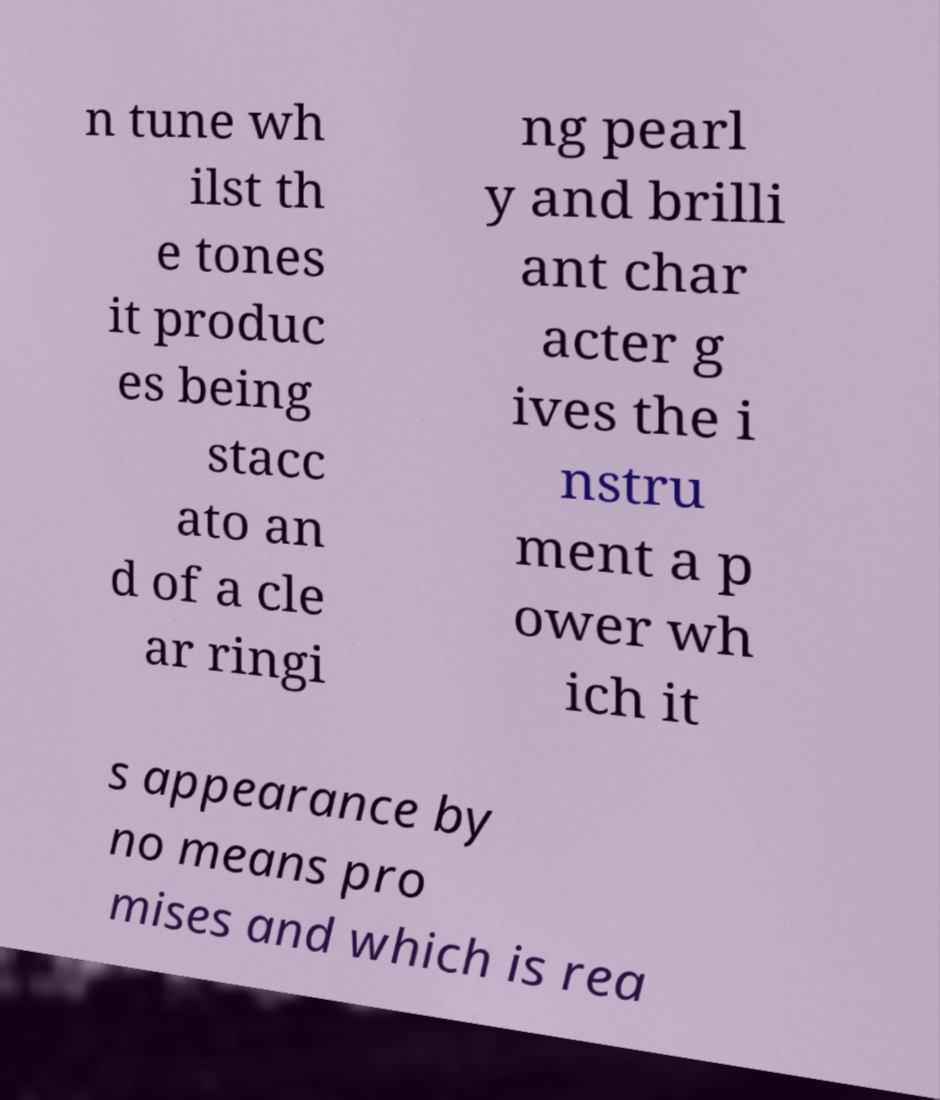Could you assist in decoding the text presented in this image and type it out clearly? n tune wh ilst th e tones it produc es being stacc ato an d of a cle ar ringi ng pearl y and brilli ant char acter g ives the i nstru ment a p ower wh ich it s appearance by no means pro mises and which is rea 